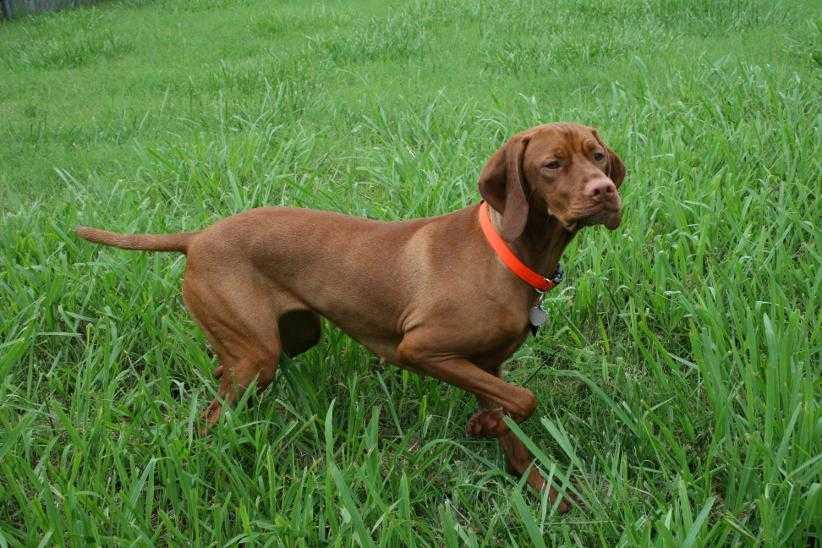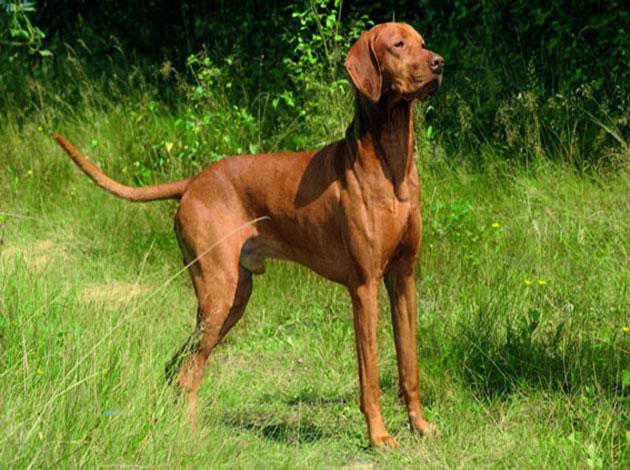The first image is the image on the left, the second image is the image on the right. For the images displayed, is the sentence "In the right image, there's a single Vizsla facing the right." factually correct? Answer yes or no. Yes. The first image is the image on the left, the second image is the image on the right. Evaluate the accuracy of this statement regarding the images: "There are at least four dogs in total.". Is it true? Answer yes or no. No. 